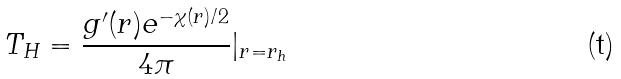<formula> <loc_0><loc_0><loc_500><loc_500>T _ { H } = \frac { g ^ { \prime } ( r ) e ^ { - \chi ( r ) / 2 } } { 4 \pi } | _ { r = r _ { h } }</formula> 